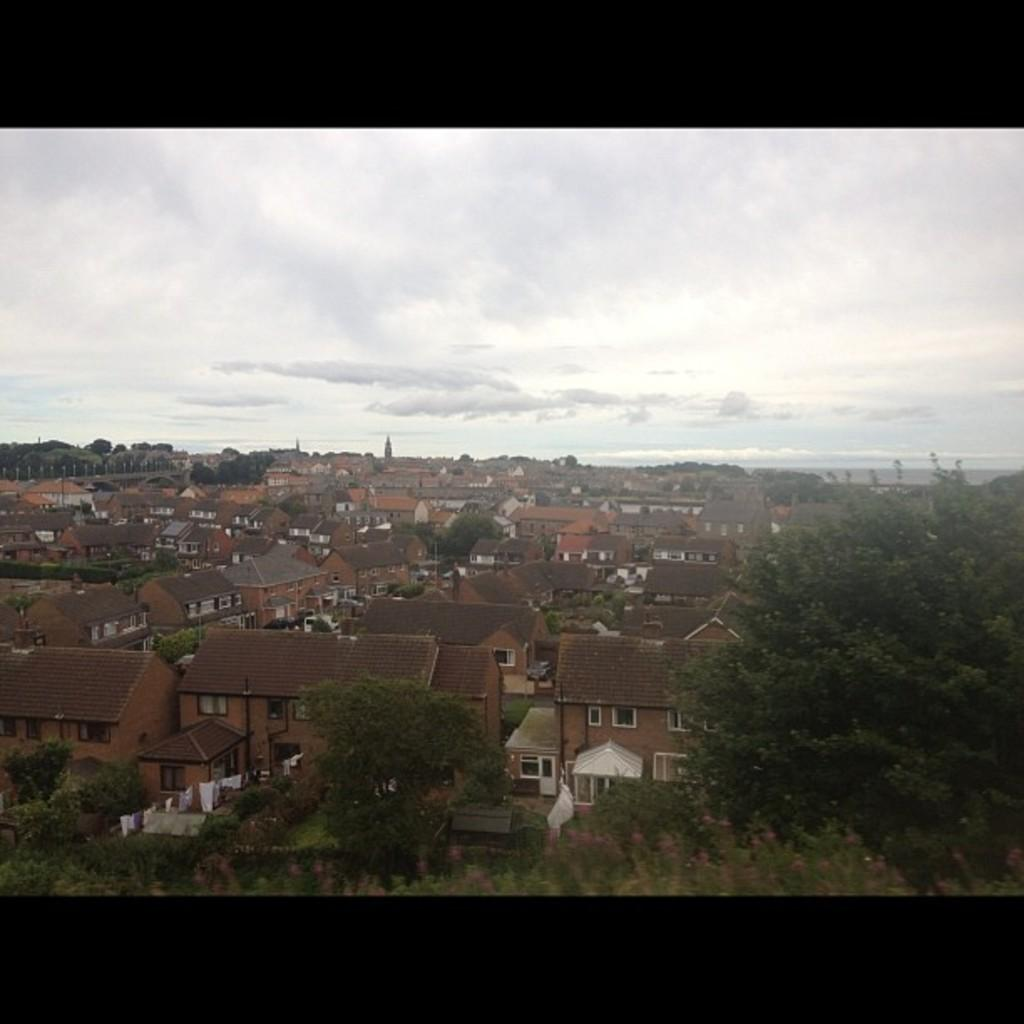What type of structures are located on the left side of the image? There are houses on the left side of the image. What type of vegetation is on the right side of the image? There are trees on the right side of the image. What is the condition of the sky in the image? The sky is cloudy at the top of the image. What type of plastic object can be seen in the image? There is no plastic object present in the image. What type of gold item is visible in the image? There is no gold item present in the image. 